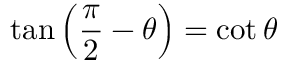Convert formula to latex. <formula><loc_0><loc_0><loc_500><loc_500>\tan \left ( { \frac { \pi } { 2 } } - \theta \right ) = \cot \theta</formula> 